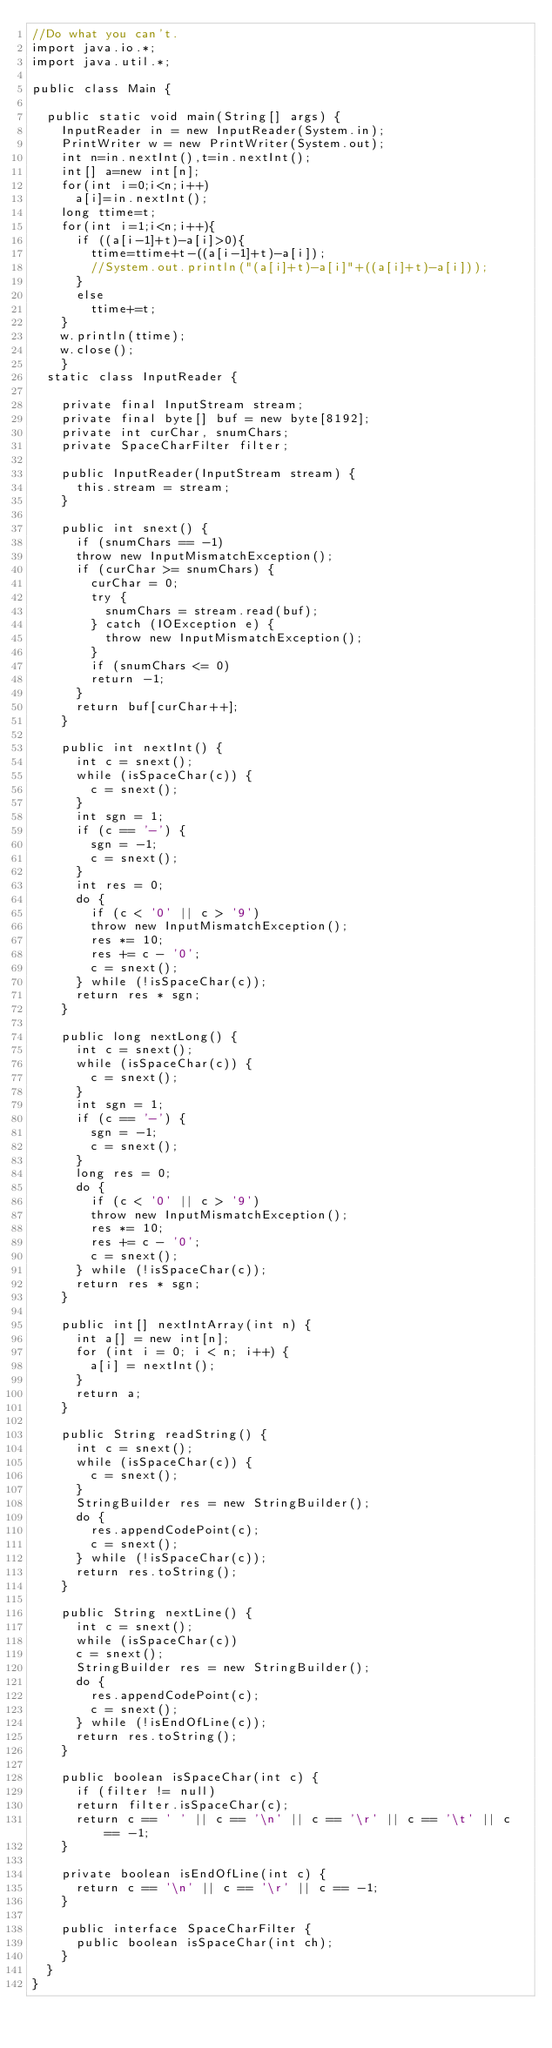<code> <loc_0><loc_0><loc_500><loc_500><_Java_>//Do what you can't.
import java.io.*;
import java.util.*;

public class Main {

  public static void main(String[] args) {
    InputReader in = new InputReader(System.in);
    PrintWriter w = new PrintWriter(System.out);
    int n=in.nextInt(),t=in.nextInt();
    int[] a=new int[n];
    for(int i=0;i<n;i++)
      a[i]=in.nextInt();
    long ttime=t;
    for(int i=1;i<n;i++){
      if ((a[i-1]+t)-a[i]>0){
        ttime=ttime+t-((a[i-1]+t)-a[i]);
        //System.out.println("(a[i]+t)-a[i]"+((a[i]+t)-a[i]));
      }
      else
        ttime+=t;
    }
    w.println(ttime);
    w.close();
    }
  static class InputReader {

    private final InputStream stream;
    private final byte[] buf = new byte[8192];
    private int curChar, snumChars;
    private SpaceCharFilter filter;

    public InputReader(InputStream stream) {
      this.stream = stream;
    }

    public int snext() {
      if (snumChars == -1)
      throw new InputMismatchException();
      if (curChar >= snumChars) {
        curChar = 0;
        try {
          snumChars = stream.read(buf);
        } catch (IOException e) {
          throw new InputMismatchException();
        }
        if (snumChars <= 0)
        return -1;
      }
      return buf[curChar++];
    }

    public int nextInt() {
      int c = snext();
      while (isSpaceChar(c)) {
        c = snext();
      }
      int sgn = 1;
      if (c == '-') {
        sgn = -1;
        c = snext();
      }
      int res = 0;
      do {
        if (c < '0' || c > '9')
        throw new InputMismatchException();
        res *= 10;
        res += c - '0';
        c = snext();
      } while (!isSpaceChar(c));
      return res * sgn;
    }

    public long nextLong() {
      int c = snext();
      while (isSpaceChar(c)) {
        c = snext();
      }
      int sgn = 1;
      if (c == '-') {
        sgn = -1;
        c = snext();
      }
      long res = 0;
      do {
        if (c < '0' || c > '9')
        throw new InputMismatchException();
        res *= 10;
        res += c - '0';
        c = snext();
      } while (!isSpaceChar(c));
      return res * sgn;
    }

    public int[] nextIntArray(int n) {
      int a[] = new int[n];
      for (int i = 0; i < n; i++) {
        a[i] = nextInt();
      }
      return a;
    }

    public String readString() {
      int c = snext();
      while (isSpaceChar(c)) {
        c = snext();
      }
      StringBuilder res = new StringBuilder();
      do {
        res.appendCodePoint(c);
        c = snext();
      } while (!isSpaceChar(c));
      return res.toString();
    }

    public String nextLine() {
      int c = snext();
      while (isSpaceChar(c))
      c = snext();
      StringBuilder res = new StringBuilder();
      do {
        res.appendCodePoint(c);
        c = snext();
      } while (!isEndOfLine(c));
      return res.toString();
    }

    public boolean isSpaceChar(int c) {
      if (filter != null)
      return filter.isSpaceChar(c);
      return c == ' ' || c == '\n' || c == '\r' || c == '\t' || c == -1;
    }

    private boolean isEndOfLine(int c) {
      return c == '\n' || c == '\r' || c == -1;
    }

    public interface SpaceCharFilter {
      public boolean isSpaceChar(int ch);
    }
  }
}
</code> 